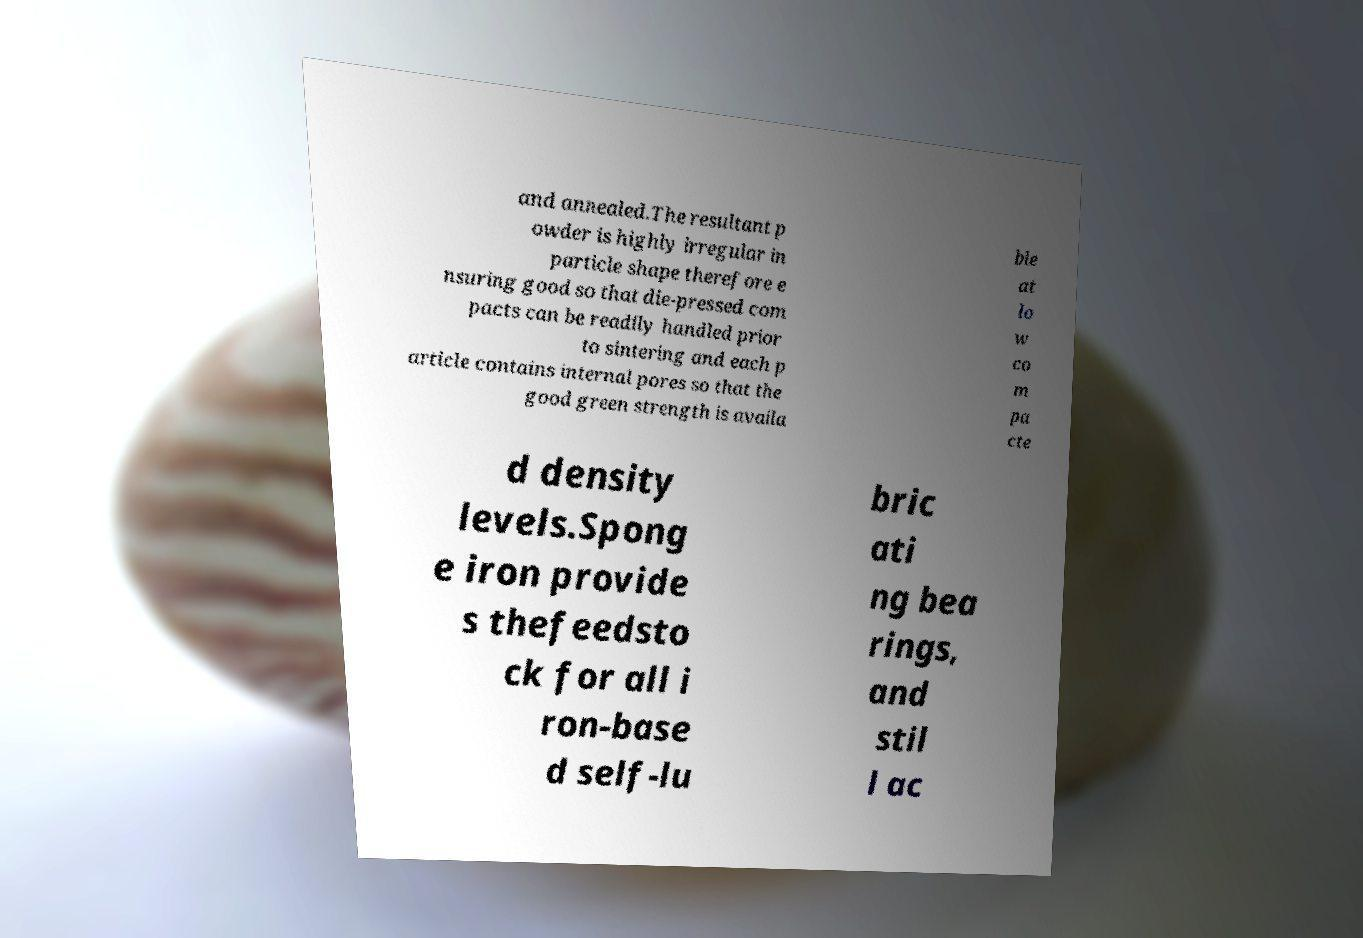Please read and relay the text visible in this image. What does it say? and annealed.The resultant p owder is highly irregular in particle shape therefore e nsuring good so that die-pressed com pacts can be readily handled prior to sintering and each p article contains internal pores so that the good green strength is availa ble at lo w co m pa cte d density levels.Spong e iron provide s thefeedsto ck for all i ron-base d self-lu bric ati ng bea rings, and stil l ac 